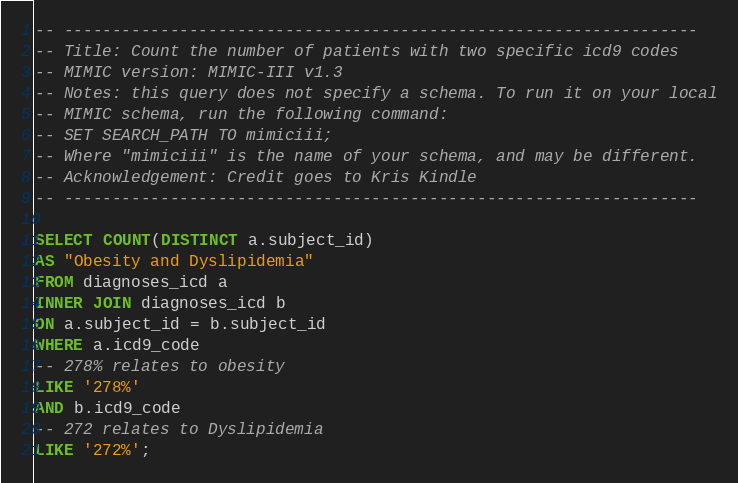<code> <loc_0><loc_0><loc_500><loc_500><_SQL_>-- ------------------------------------------------------------------
-- Title: Count the number of patients with two specific icd9 codes
-- MIMIC version: MIMIC-III v1.3
-- Notes: this query does not specify a schema. To run it on your local
-- MIMIC schema, run the following command:
-- SET SEARCH_PATH TO mimiciii;
-- Where "mimiciii" is the name of your schema, and may be different.
-- Acknowledgement: Credit goes to Kris Kindle
-- ------------------------------------------------------------------

SELECT COUNT(DISTINCT a.subject_id) 
AS "Obesity and Dyslipidemia" 
FROM diagnoses_icd a 
INNER JOIN diagnoses_icd b 
ON a.subject_id = b.subject_id 
WHERE a.icd9_code
-- 278% relates to obesity 
LIKE '278%' 
AND b.icd9_code 
-- 272 relates to Dyslipidemia
LIKE '272%';</code> 